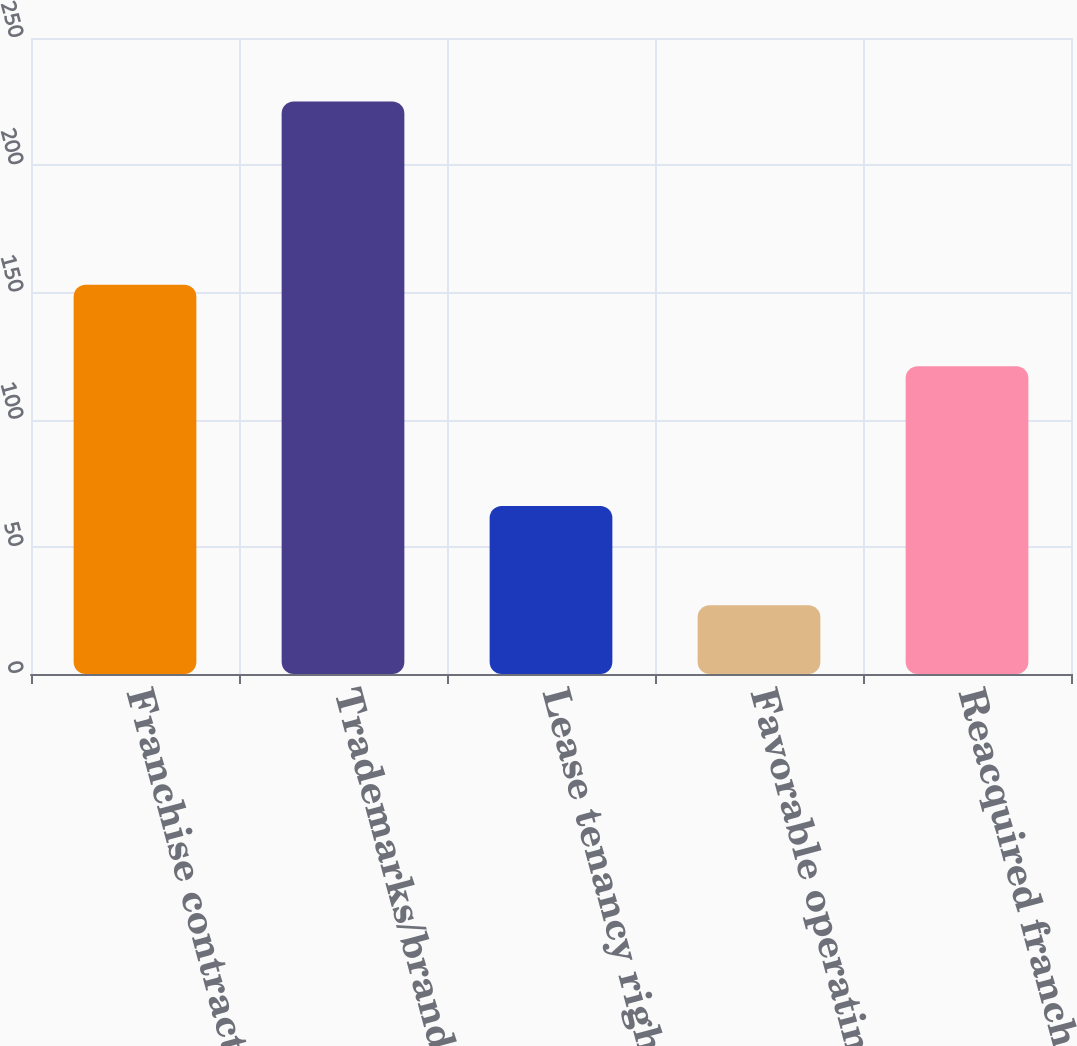Convert chart to OTSL. <chart><loc_0><loc_0><loc_500><loc_500><bar_chart><fcel>Franchise contract rights<fcel>Trademarks/brands<fcel>Lease tenancy rights<fcel>Favorable operating leases<fcel>Reacquired franchise rights<nl><fcel>153<fcel>225<fcel>66<fcel>27<fcel>121<nl></chart> 